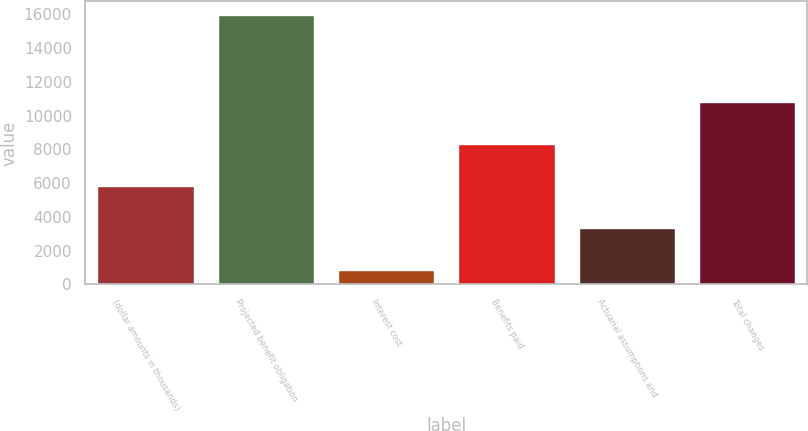Convert chart. <chart><loc_0><loc_0><loc_500><loc_500><bar_chart><fcel>(dollar amounts in thousands)<fcel>Projected benefit obligation<fcel>Interest cost<fcel>Benefits paid<fcel>Actuarial assumptions and<fcel>Total changes<nl><fcel>5818.6<fcel>15963<fcel>856<fcel>8299.9<fcel>3337.3<fcel>10781.2<nl></chart> 